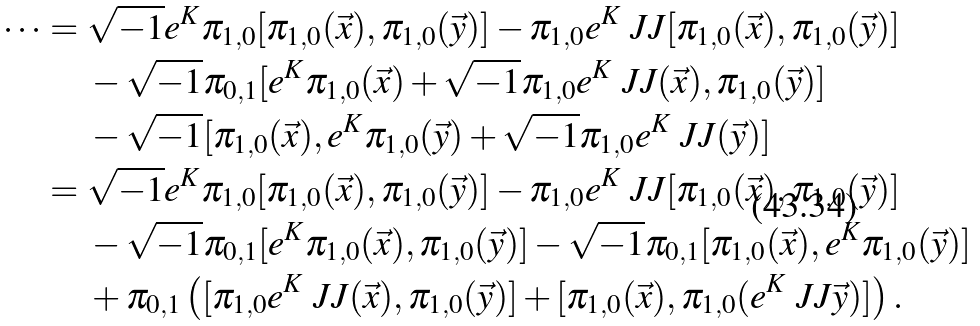Convert formula to latex. <formula><loc_0><loc_0><loc_500><loc_500>\dots = & \ \sqrt { - 1 } e ^ { K } \pi _ { 1 , 0 } [ \pi _ { 1 , 0 } ( \vec { x } ) , \pi _ { 1 , 0 } ( \vec { y } ) ] - \pi _ { 1 , 0 } e ^ { K } \ J J [ \pi _ { 1 , 0 } ( \vec { x } ) , \pi _ { 1 , 0 } ( \vec { y } ) ] \\ & \ - \sqrt { - 1 } \pi _ { 0 , 1 } [ e ^ { K } \pi _ { 1 , 0 } ( \vec { x } ) + \sqrt { - 1 } \pi _ { 1 , 0 } e ^ { K } \ J J ( \vec { x } ) , \pi _ { 1 , 0 } ( \vec { y } ) ] \\ & \ - \sqrt { - 1 } [ \pi _ { 1 , 0 } ( \vec { x } ) , e ^ { K } \pi _ { 1 , 0 } ( \vec { y } ) + \sqrt { - 1 } \pi _ { 1 , 0 } e ^ { K } \ J J ( \vec { y } ) ] \\ = & \ \sqrt { - 1 } e ^ { K } \pi _ { 1 , 0 } [ \pi _ { 1 , 0 } ( \vec { x } ) , \pi _ { 1 , 0 } ( \vec { y } ) ] - \pi _ { 1 , 0 } e ^ { K } \ J J [ \pi _ { 1 , 0 } ( \vec { x } ) , \pi _ { 1 , 0 } ( \vec { y } ) ] \\ & \ - \sqrt { - 1 } \pi _ { 0 , 1 } [ e ^ { K } \pi _ { 1 , 0 } ( \vec { x } ) , \pi _ { 1 , 0 } ( \vec { y } ) ] - \sqrt { - 1 } \pi _ { 0 , 1 } [ \pi _ { 1 , 0 } ( \vec { x } ) , e ^ { K } \pi _ { 1 , 0 } ( \vec { y } ) ] \\ & \ + \pi _ { 0 , 1 } \left ( [ \pi _ { 1 , 0 } e ^ { K } \ J J ( \vec { x } ) , \pi _ { 1 , 0 } ( \vec { y } ) ] + [ \pi _ { 1 , 0 } ( \vec { x } ) , \pi _ { 1 , 0 } ( e ^ { K } \ J J \vec { y } ) ] \right ) .</formula> 